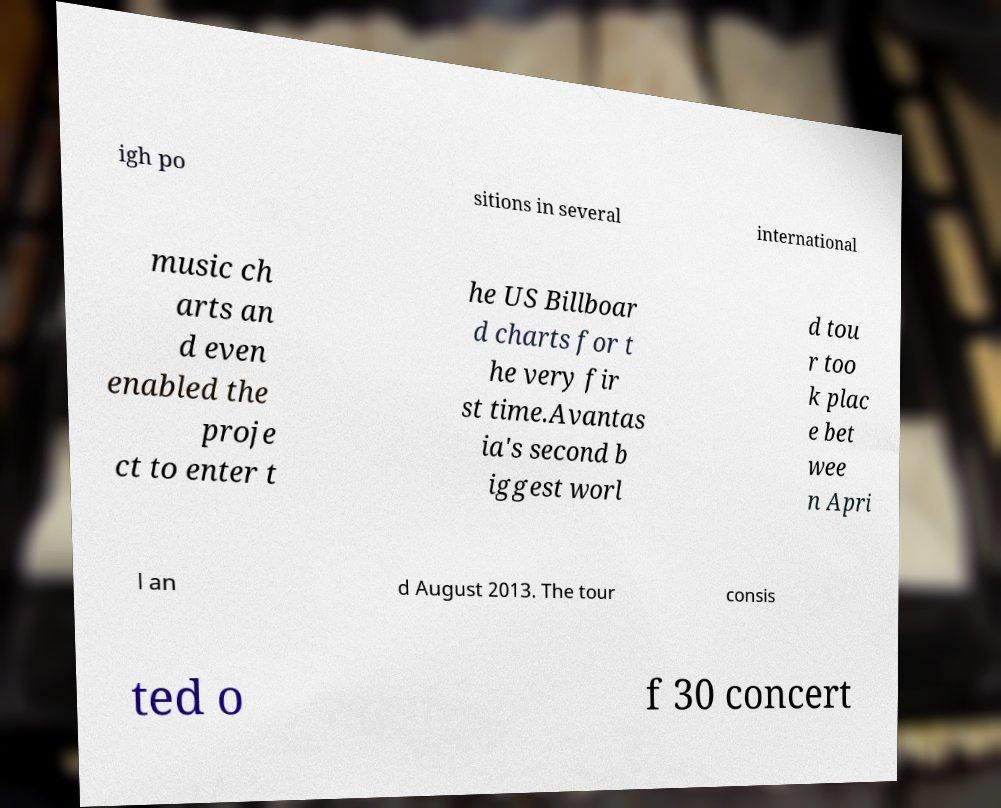What messages or text are displayed in this image? I need them in a readable, typed format. igh po sitions in several international music ch arts an d even enabled the proje ct to enter t he US Billboar d charts for t he very fir st time.Avantas ia's second b iggest worl d tou r too k plac e bet wee n Apri l an d August 2013. The tour consis ted o f 30 concert 